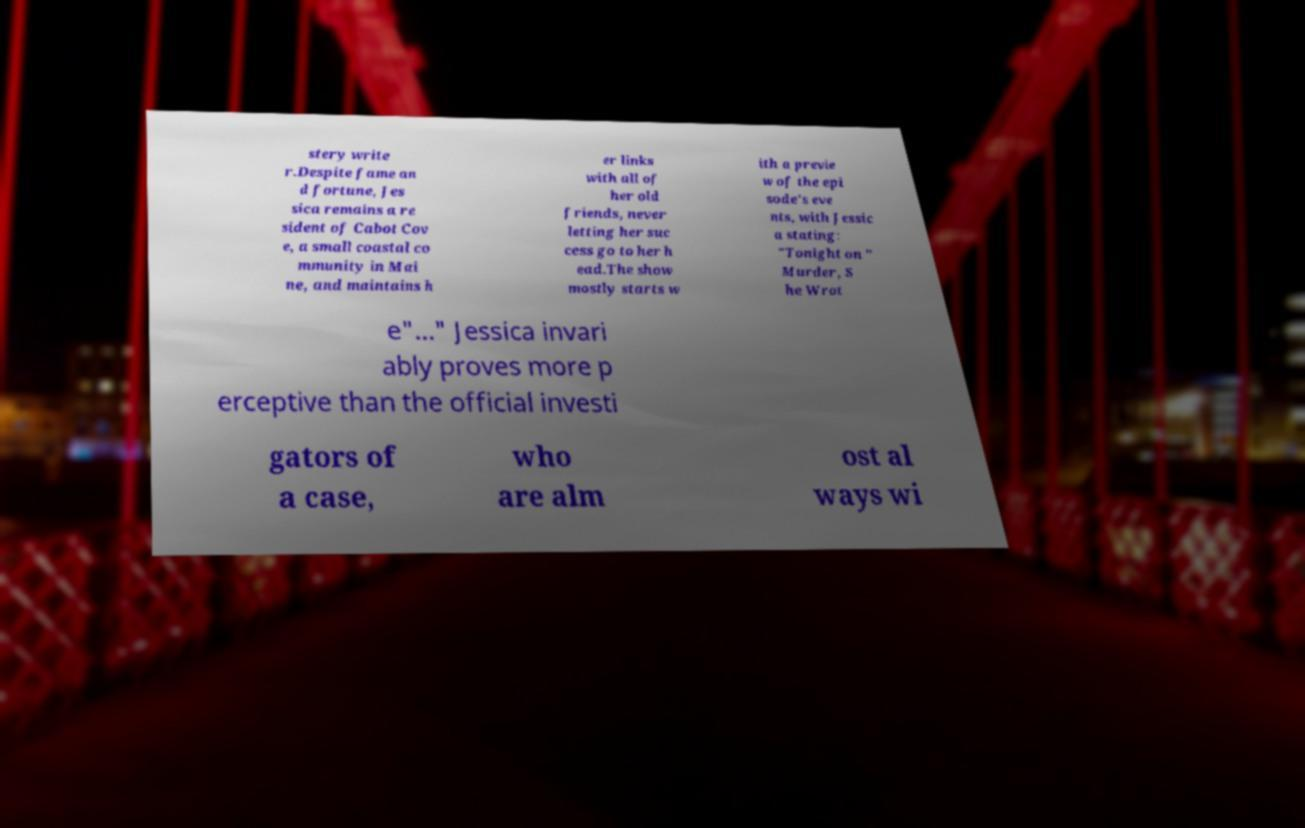There's text embedded in this image that I need extracted. Can you transcribe it verbatim? stery write r.Despite fame an d fortune, Jes sica remains a re sident of Cabot Cov e, a small coastal co mmunity in Mai ne, and maintains h er links with all of her old friends, never letting her suc cess go to her h ead.The show mostly starts w ith a previe w of the epi sode's eve nts, with Jessic a stating: "Tonight on " Murder, S he Wrot e"..." Jessica invari ably proves more p erceptive than the official investi gators of a case, who are alm ost al ways wi 